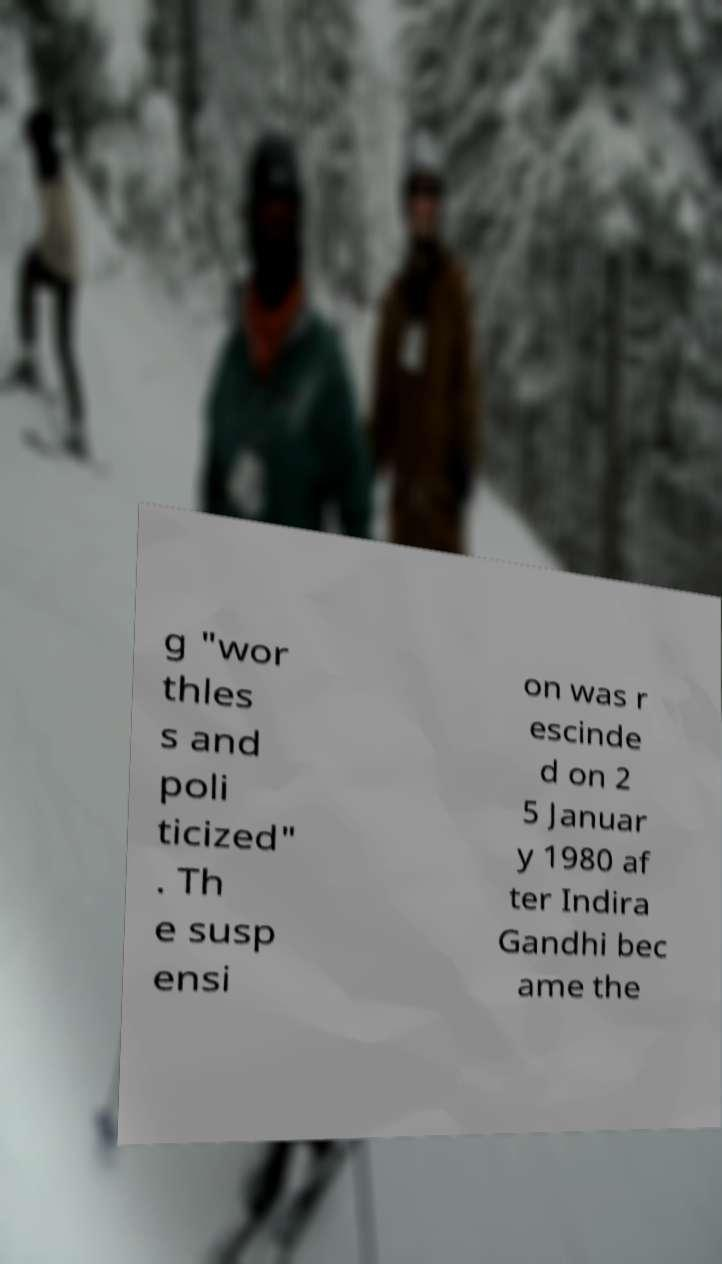What messages or text are displayed in this image? I need them in a readable, typed format. g "wor thles s and poli ticized" . Th e susp ensi on was r escinde d on 2 5 Januar y 1980 af ter Indira Gandhi bec ame the 